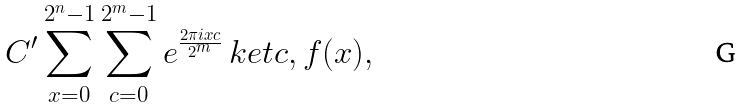Convert formula to latex. <formula><loc_0><loc_0><loc_500><loc_500>C ^ { \prime } \sum _ { x = 0 } ^ { 2 ^ { n } - 1 } \sum _ { c = 0 } ^ { 2 ^ { m } - 1 } e ^ { \frac { 2 \pi i x c } { 2 ^ { m } } } \ k e t { c , f ( x ) } ,</formula> 